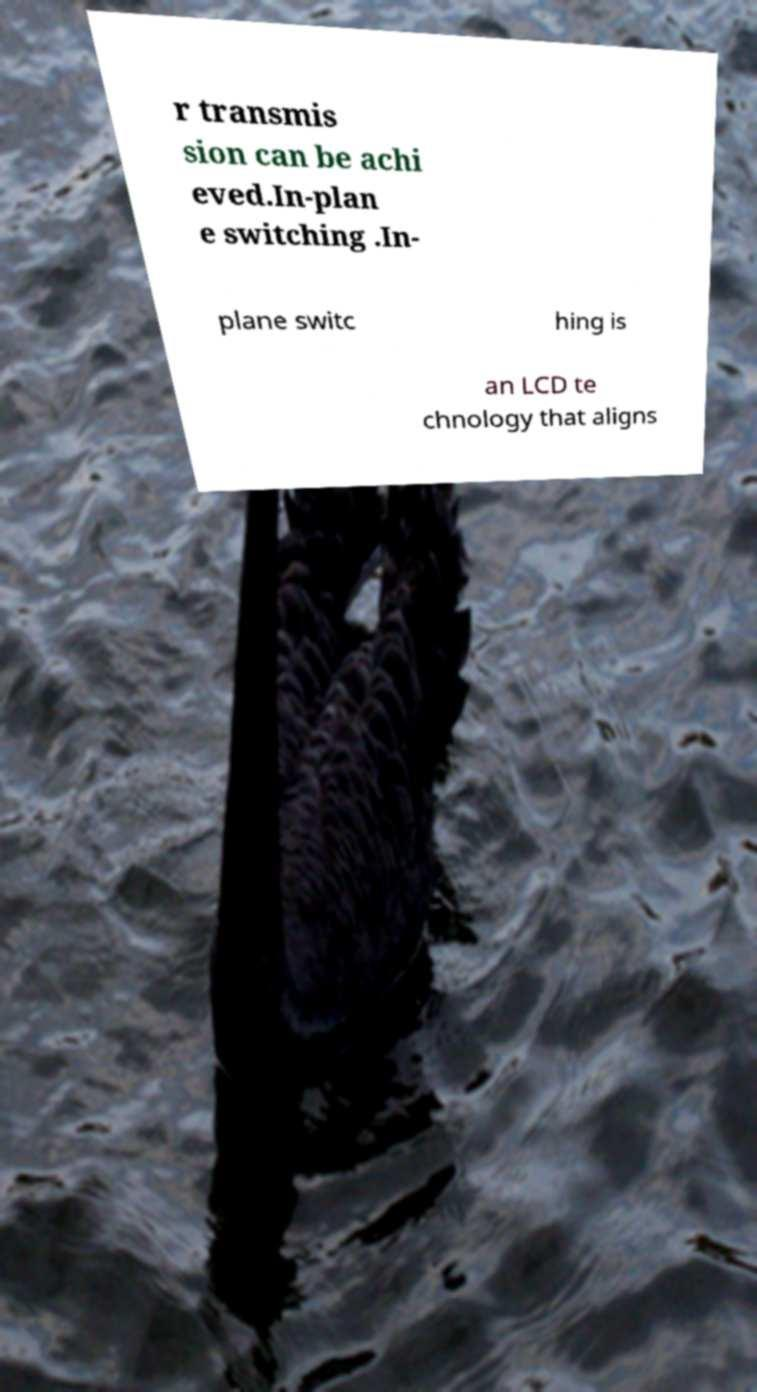I need the written content from this picture converted into text. Can you do that? r transmis sion can be achi eved.In-plan e switching .In- plane switc hing is an LCD te chnology that aligns 